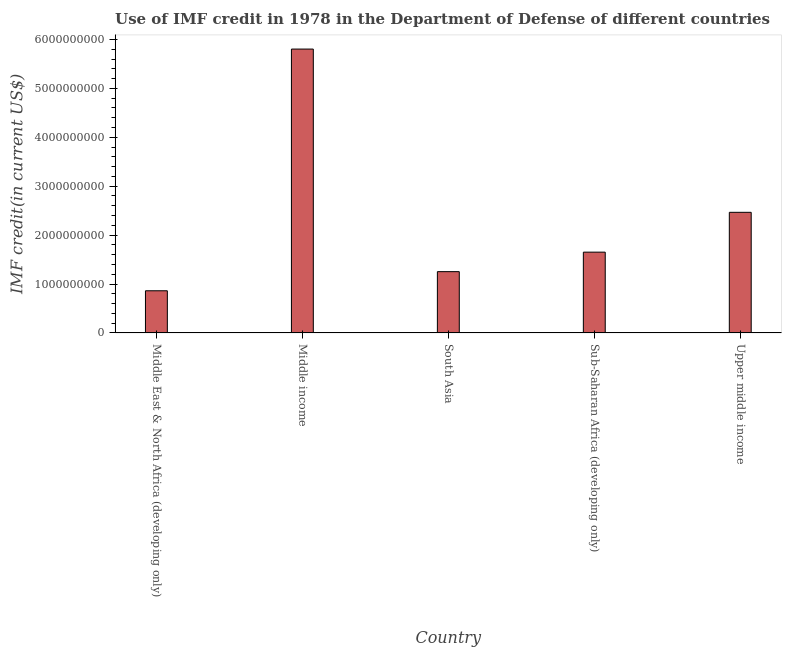What is the title of the graph?
Offer a very short reply. Use of IMF credit in 1978 in the Department of Defense of different countries. What is the label or title of the Y-axis?
Make the answer very short. IMF credit(in current US$). What is the use of imf credit in dod in South Asia?
Make the answer very short. 1.25e+09. Across all countries, what is the maximum use of imf credit in dod?
Give a very brief answer. 5.80e+09. Across all countries, what is the minimum use of imf credit in dod?
Your answer should be compact. 8.62e+08. In which country was the use of imf credit in dod minimum?
Your answer should be very brief. Middle East & North Africa (developing only). What is the sum of the use of imf credit in dod?
Your answer should be compact. 1.20e+1. What is the difference between the use of imf credit in dod in Middle income and South Asia?
Ensure brevity in your answer.  4.55e+09. What is the average use of imf credit in dod per country?
Provide a succinct answer. 2.41e+09. What is the median use of imf credit in dod?
Ensure brevity in your answer.  1.65e+09. In how many countries, is the use of imf credit in dod greater than 2800000000 US$?
Your response must be concise. 1. What is the ratio of the use of imf credit in dod in Middle income to that in Upper middle income?
Offer a terse response. 2.35. Is the use of imf credit in dod in Middle income less than that in Sub-Saharan Africa (developing only)?
Your response must be concise. No. Is the difference between the use of imf credit in dod in Middle income and Sub-Saharan Africa (developing only) greater than the difference between any two countries?
Ensure brevity in your answer.  No. What is the difference between the highest and the second highest use of imf credit in dod?
Your answer should be compact. 3.34e+09. What is the difference between the highest and the lowest use of imf credit in dod?
Keep it short and to the point. 4.94e+09. How many countries are there in the graph?
Ensure brevity in your answer.  5. What is the IMF credit(in current US$) in Middle East & North Africa (developing only)?
Make the answer very short. 8.62e+08. What is the IMF credit(in current US$) in Middle income?
Provide a short and direct response. 5.80e+09. What is the IMF credit(in current US$) of South Asia?
Your response must be concise. 1.25e+09. What is the IMF credit(in current US$) in Sub-Saharan Africa (developing only)?
Your answer should be compact. 1.65e+09. What is the IMF credit(in current US$) in Upper middle income?
Keep it short and to the point. 2.47e+09. What is the difference between the IMF credit(in current US$) in Middle East & North Africa (developing only) and Middle income?
Give a very brief answer. -4.94e+09. What is the difference between the IMF credit(in current US$) in Middle East & North Africa (developing only) and South Asia?
Keep it short and to the point. -3.91e+08. What is the difference between the IMF credit(in current US$) in Middle East & North Africa (developing only) and Sub-Saharan Africa (developing only)?
Offer a terse response. -7.90e+08. What is the difference between the IMF credit(in current US$) in Middle East & North Africa (developing only) and Upper middle income?
Your answer should be compact. -1.60e+09. What is the difference between the IMF credit(in current US$) in Middle income and South Asia?
Your answer should be very brief. 4.55e+09. What is the difference between the IMF credit(in current US$) in Middle income and Sub-Saharan Africa (developing only)?
Offer a terse response. 4.15e+09. What is the difference between the IMF credit(in current US$) in Middle income and Upper middle income?
Make the answer very short. 3.34e+09. What is the difference between the IMF credit(in current US$) in South Asia and Sub-Saharan Africa (developing only)?
Give a very brief answer. -3.98e+08. What is the difference between the IMF credit(in current US$) in South Asia and Upper middle income?
Provide a succinct answer. -1.21e+09. What is the difference between the IMF credit(in current US$) in Sub-Saharan Africa (developing only) and Upper middle income?
Provide a short and direct response. -8.14e+08. What is the ratio of the IMF credit(in current US$) in Middle East & North Africa (developing only) to that in Middle income?
Offer a very short reply. 0.15. What is the ratio of the IMF credit(in current US$) in Middle East & North Africa (developing only) to that in South Asia?
Your answer should be compact. 0.69. What is the ratio of the IMF credit(in current US$) in Middle East & North Africa (developing only) to that in Sub-Saharan Africa (developing only)?
Your answer should be compact. 0.52. What is the ratio of the IMF credit(in current US$) in Middle income to that in South Asia?
Provide a succinct answer. 4.63. What is the ratio of the IMF credit(in current US$) in Middle income to that in Sub-Saharan Africa (developing only)?
Your answer should be compact. 3.51. What is the ratio of the IMF credit(in current US$) in Middle income to that in Upper middle income?
Your answer should be very brief. 2.35. What is the ratio of the IMF credit(in current US$) in South Asia to that in Sub-Saharan Africa (developing only)?
Give a very brief answer. 0.76. What is the ratio of the IMF credit(in current US$) in South Asia to that in Upper middle income?
Your response must be concise. 0.51. What is the ratio of the IMF credit(in current US$) in Sub-Saharan Africa (developing only) to that in Upper middle income?
Make the answer very short. 0.67. 